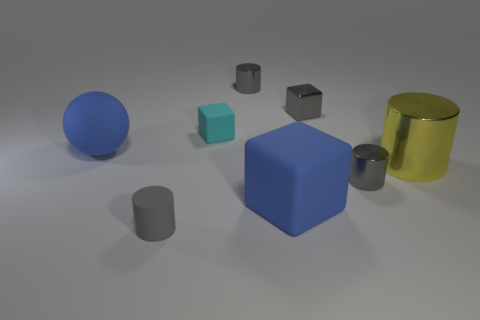How many objects are present, and can you classify them by shape? In total, there are seven objects in the image. These consist of one sphere, one cube, one larger cube, two cylinders of differing sizes, one smaller cube, and one larger cylinder. The objects are geometrically shaped and arranged with ample space between them. 